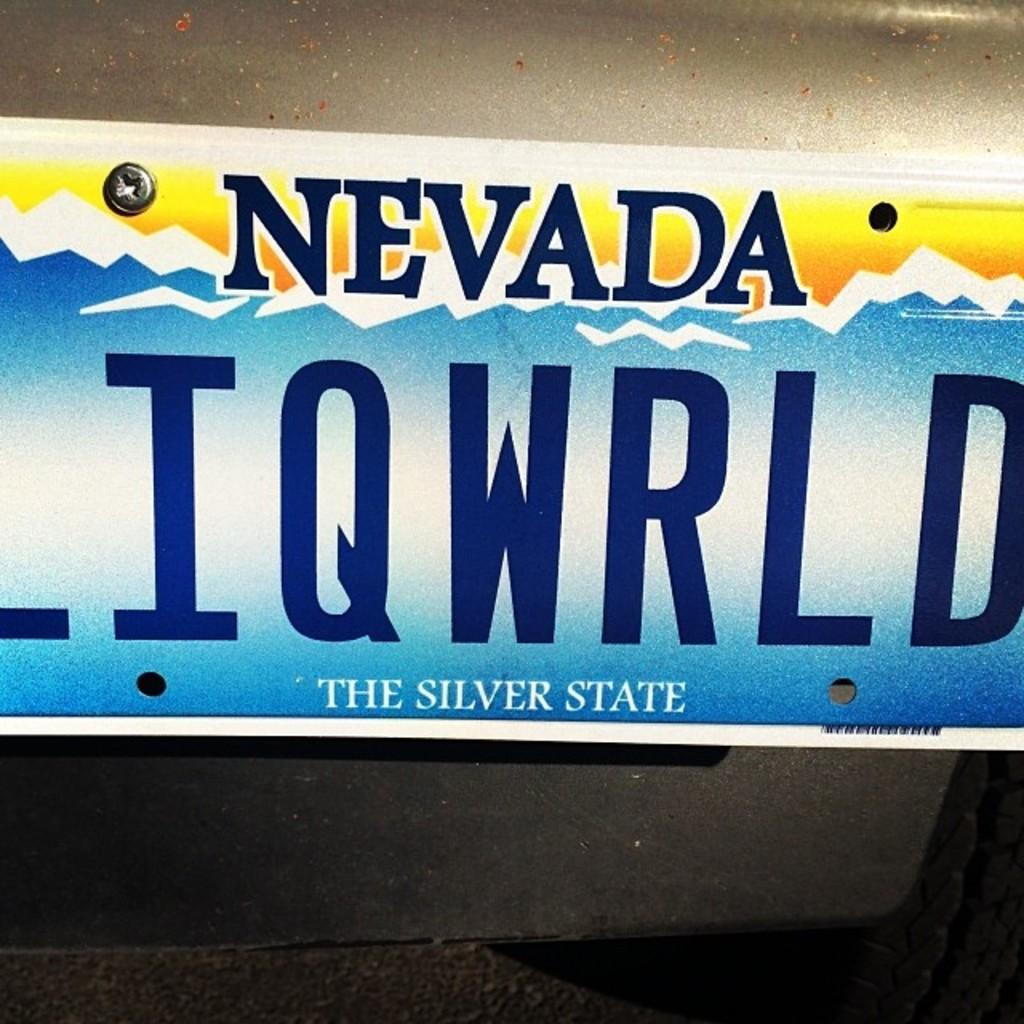Provide a one-sentence caption for the provided image. a nevada license plate that says LIQWRLD, the silver state. 